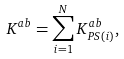Convert formula to latex. <formula><loc_0><loc_0><loc_500><loc_500>K ^ { a b } = \sum _ { i = 1 } ^ { N } K _ { P S ( i ) } ^ { a b } ,</formula> 